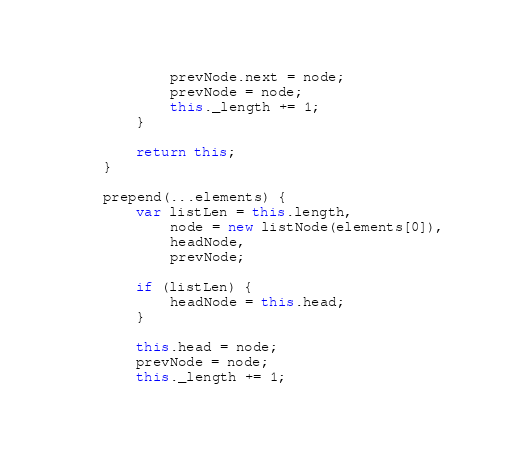Convert code to text. <code><loc_0><loc_0><loc_500><loc_500><_JavaScript_>            prevNode.next = node;
            prevNode = node;
            this._length += 1;
        }

        return this;
    }

    prepend(...elements) {
        var listLen = this.length,
            node = new listNode(elements[0]),
            headNode,
            prevNode;
        
        if (listLen) {
            headNode = this.head;
        }

        this.head = node;
        prevNode = node;
        this._length += 1;
</code> 